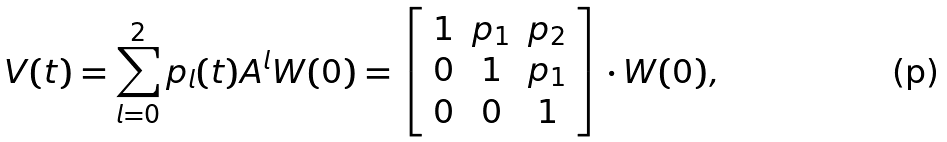<formula> <loc_0><loc_0><loc_500><loc_500>V ( t ) = \sum _ { l = 0 } ^ { 2 } p _ { l } ( t ) A ^ { l } W ( 0 ) = \left [ \begin{array} { c c c } 1 & p _ { 1 } & p _ { 2 } \\ 0 & 1 & p _ { 1 } \\ 0 & 0 & 1 \end{array} \right ] \cdot W ( 0 ) ,</formula> 